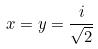<formula> <loc_0><loc_0><loc_500><loc_500>x = y = \frac { i } { \sqrt { 2 } }</formula> 